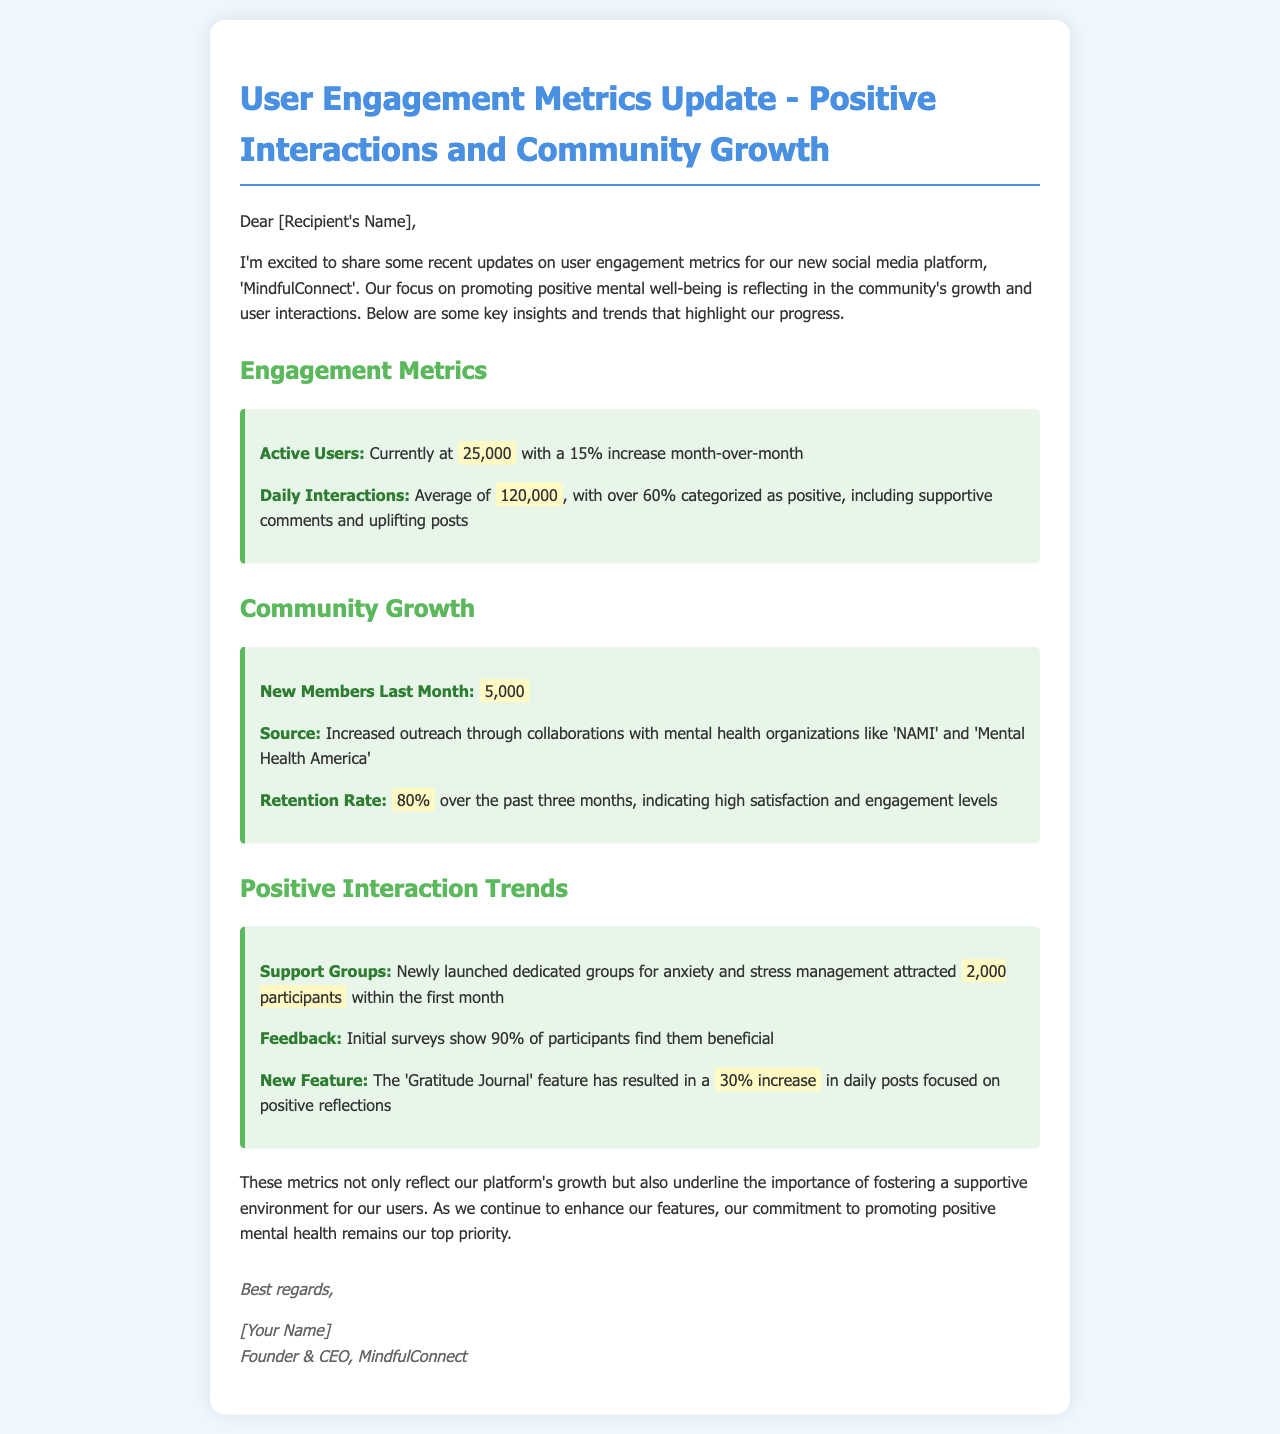What is the current number of active users? The document states the current active users as 25,000.
Answer: 25,000 What percentage of daily interactions are positive? The document indicates that over 60% of daily interactions are categorized as positive.
Answer: 60% How many new members joined last month? The document mentions that 5,000 new members joined last month.
Answer: 5,000 What is the retention rate over the past three months? The document reports the retention rate as 80%.
Answer: 80% How many participants joined the new support groups in the first month? The document indicates that 2,000 participants joined the newly launched support groups.
Answer: 2,000 What is the increase in daily posts due to the Gratitude Journal feature? The document states that there is a 30% increase in daily posts focused on positive reflections due to the Gratitude Journal feature.
Answer: 30% Who are the organizations mentioned that contributed to the increased outreach? The document lists 'NAMI' and 'Mental Health America' as collaborating organizations.
Answer: NAMI and Mental Health America What percentage of participants find the support groups beneficial? The document mentions that 90% of participants find the support groups beneficial.
Answer: 90% What is the average number of daily interactions? The document states the average number of daily interactions as 120,000.
Answer: 120,000 